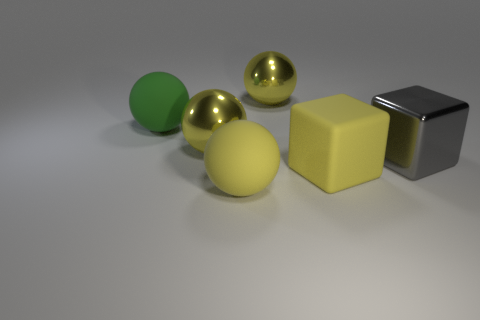Are there any yellow matte objects that have the same shape as the gray metallic object?
Your answer should be very brief. Yes. The rubber thing that is on the right side of the big yellow rubber thing that is left of the big yellow rubber cube is what shape?
Ensure brevity in your answer.  Cube. What number of yellow objects are made of the same material as the green sphere?
Provide a short and direct response. 2. The cube that is the same material as the green sphere is what color?
Offer a very short reply. Yellow. Is the number of large rubber blocks less than the number of tiny red matte cylinders?
Your answer should be compact. No. What color is the other large matte object that is the same shape as the gray object?
Give a very brief answer. Yellow. There is a big rubber sphere right of the rubber sphere behind the gray thing; is there a big yellow matte block that is in front of it?
Offer a very short reply. No. Do the large green rubber thing and the gray thing have the same shape?
Provide a succinct answer. No. Is the number of spheres that are to the right of the large green matte object less than the number of tiny brown cubes?
Ensure brevity in your answer.  No. What color is the big matte cube that is in front of the large shiny ball behind the large rubber sphere that is left of the big yellow rubber sphere?
Make the answer very short. Yellow. 